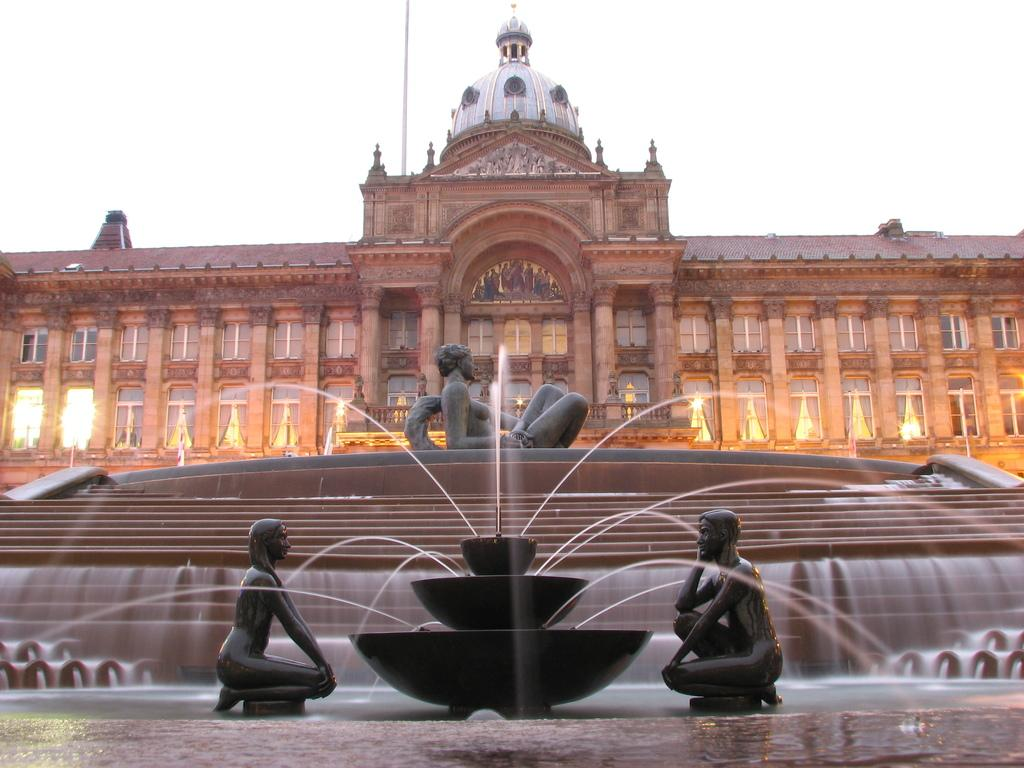What is located in the foreground of the image? There is a fountain and a waterfall in the foreground of the image. What type of structures can be seen in the image? There are statues in the image. What is visible in the background of the image? There is a building in the background of the image. How would you describe the sky in the image? The sky is clear in the image. What type of wool is being used to create the statues in the image? There is no wool present in the image, as the statues are not made of wool. Can you tell me how the toad feels about the waterfall in the image? There are no toads present in the image, so it is not possible to determine their feelings about the waterfall. 